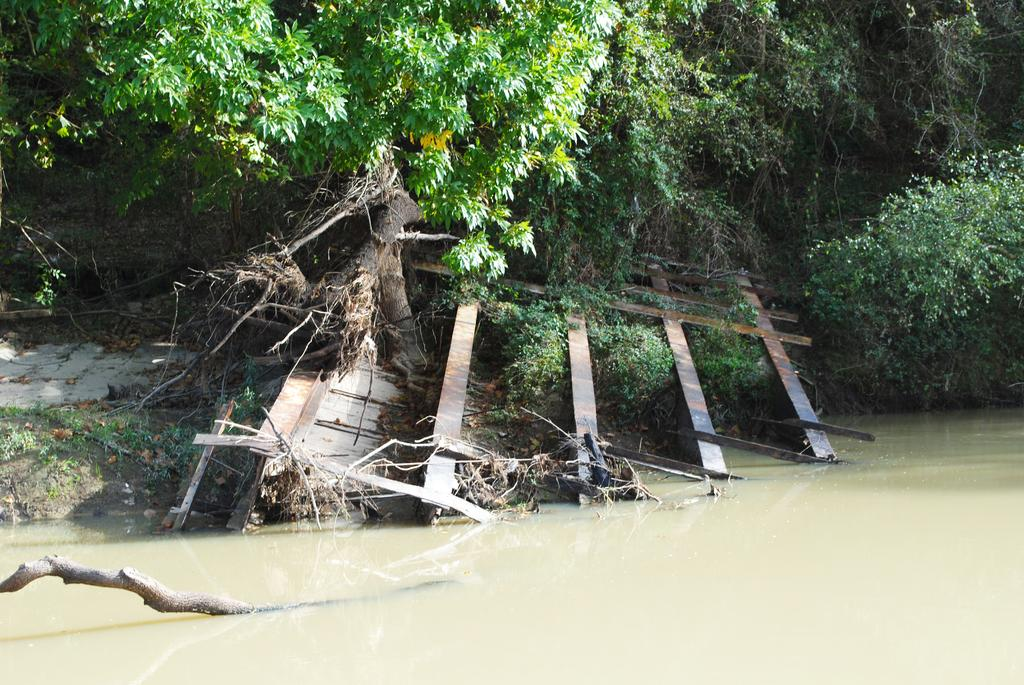What is located at the bottom of the image? There is a branch of a tree in the water at the bottom of the image. What can be seen in the background of the image? There are trees, plants, dry leaves, wood objects, and iron objects visible in the background of the image. What hobbies are the leaves in the image engaged in? The leaves in the image are not engaged in any hobbies, as they are inanimate objects. Can you read the note that is attached to the branch in the image? There is no note attached to the branch in the image. 